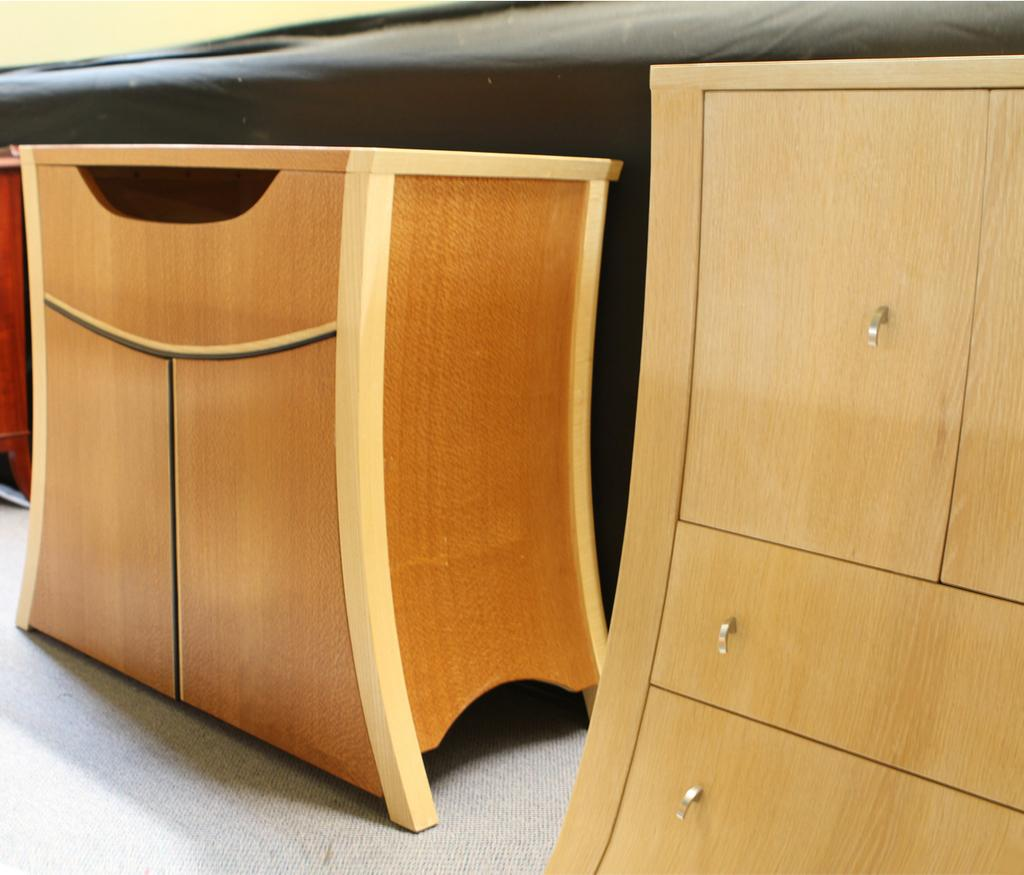What type of furniture is present in the image? There are wooden cupboards in the image. What part of the room can be seen in the image? The floor is visible in the image. What type of cast can be seen on the dinosaur's nerve in the image? There are no dinosaurs or casts present in the image; it features wooden cupboards and a visible floor. 